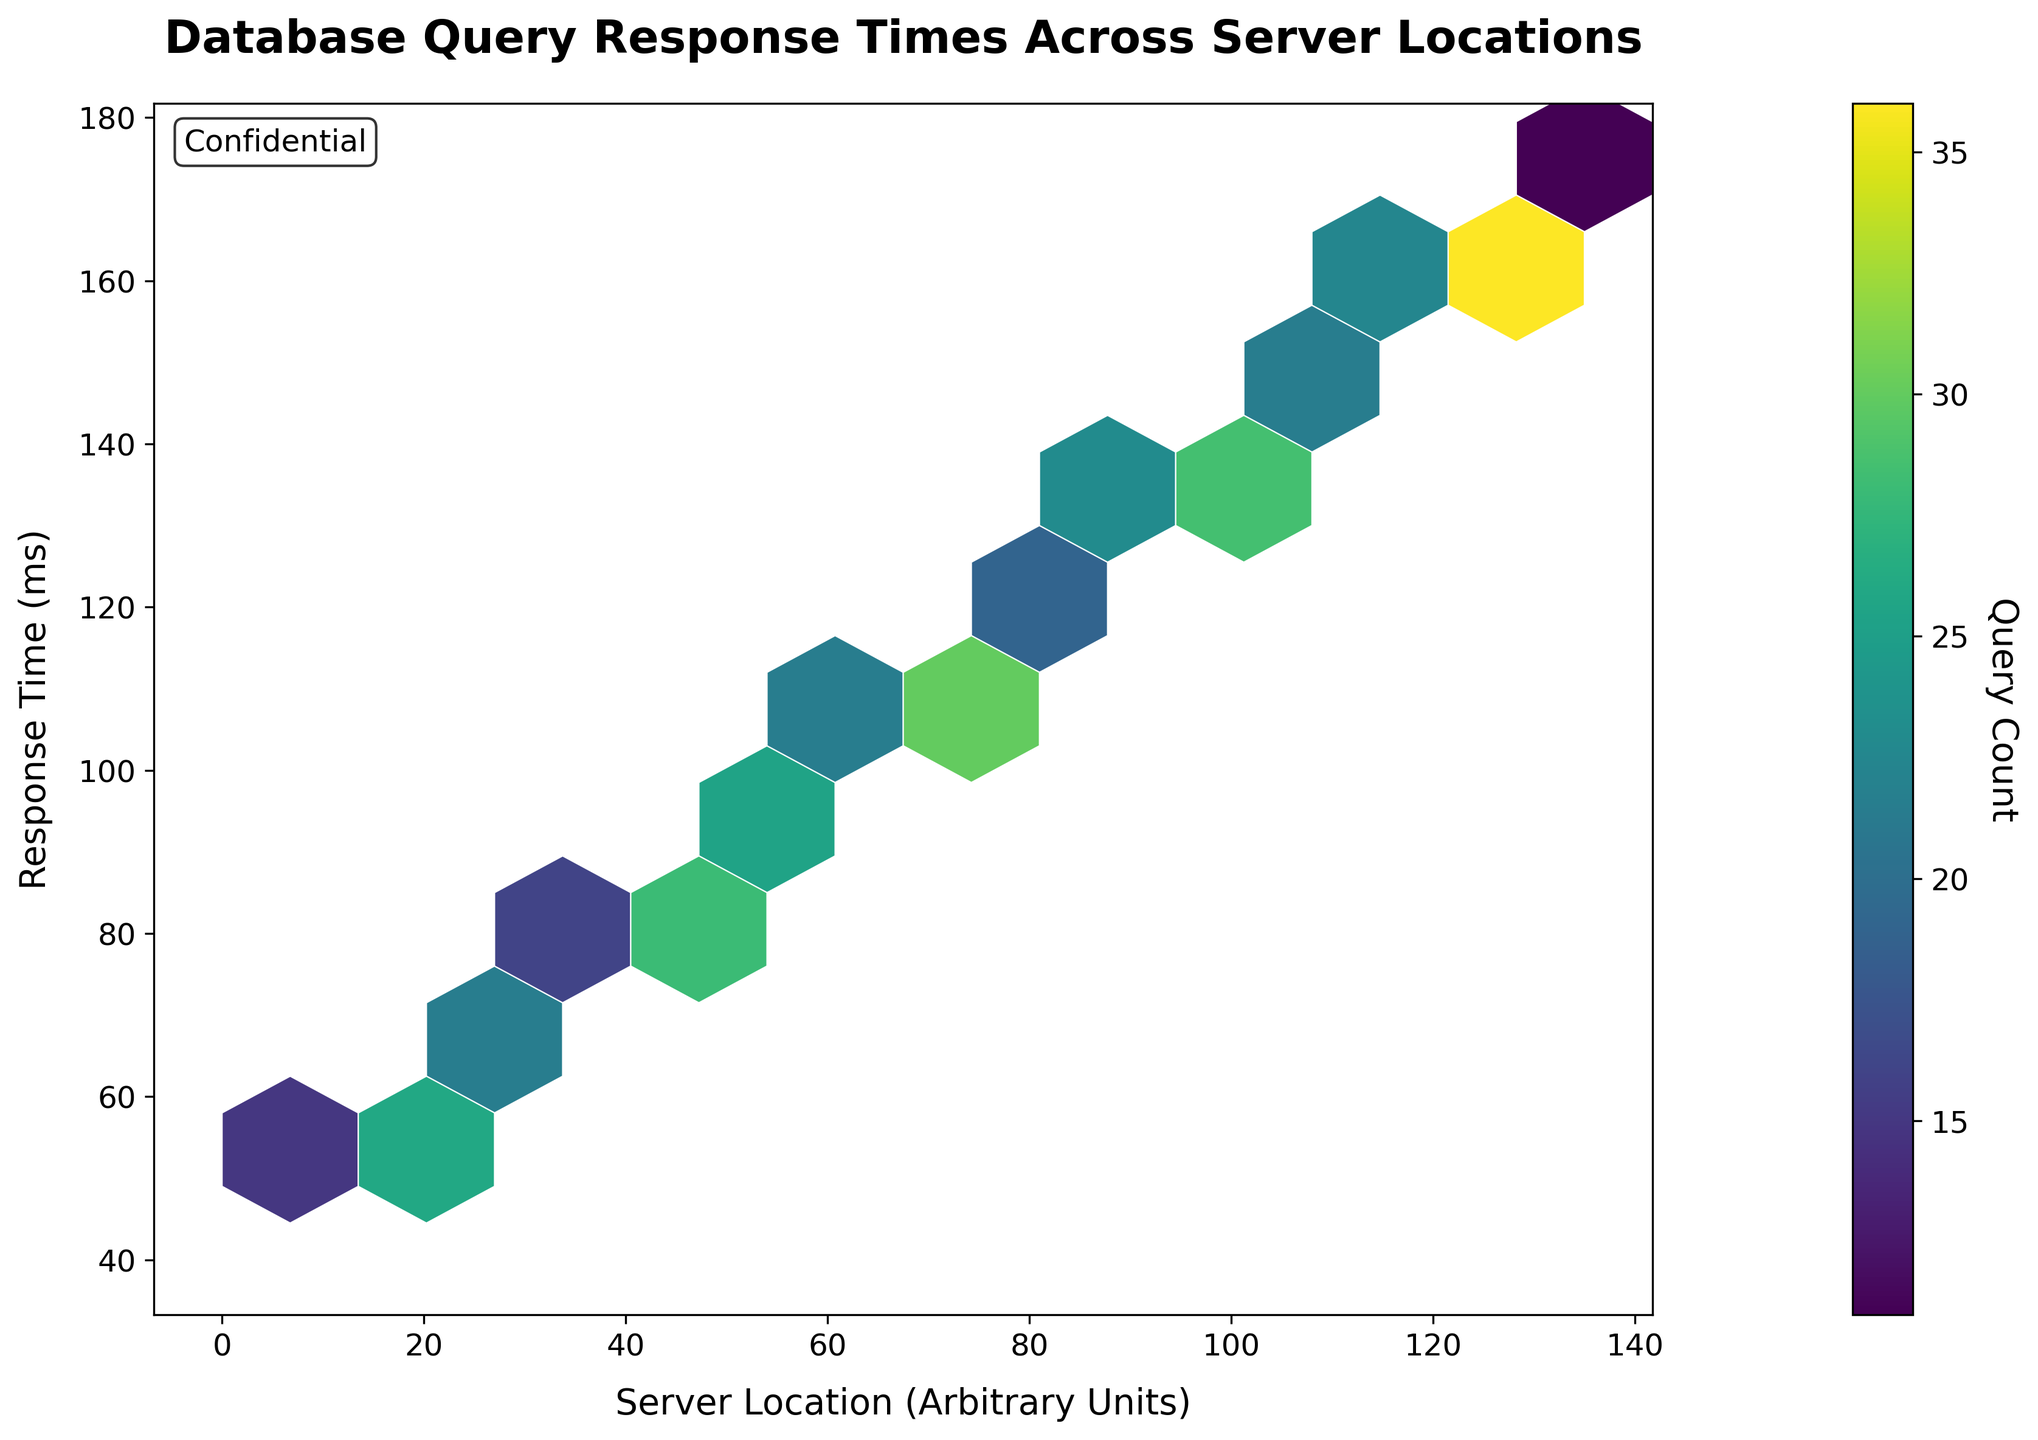What is the title of the figure? The title of the figure is displayed prominently at the top. It reads "Database Query Response Times Across Server Locations".
Answer: Database Query Response Times Across Server Locations What color scheme is used in the hexbin plot? The color scheme is described near the color bar legend; the plot uses the 'viridis' colormap, but the figure mostly shows different shades of green, yellow, blue, and purple.
Answer: viridis What are the units of the x-axis? The x-axis label provides information on the units, which are "Server Location (Arbitrary Units)".
Answer: Server Location (Arbitrary Units) What is the range of the y-axis? By looking at the y-axis, we see it ranges from 40 to 175.
Answer: 40 to 175 Which server location has the highest query count? The point with the highest query count can be identified by the darkest hexagons in the plot, corresponding to a location around 125 on the x-axis.
Answer: Around 125 What's the median server location for the queries plotted? Median server location can be found by ordering all x-values and identifying the middle one. With ordered values from 10 to 130, the median is halfway between locations 65 and 70.
Answer: 67.5 How many hexagons are displayed in the hexbin plot? Counting the visible hexagons in the plot involves considering the grid size of 10. The number of hexagons can be approximated by checking the horizontal and vertical extents shown in the figure.
Answer: Around 15-20 hexagons What is the approximate query count for the response time of 100ms? The color bar indicates the count, and hexagons shaded near y=100ms should be referenced to the color bar; hexagons at 100ms align with counts around 24.
Answer: About 24 For the server locations 105 and 115, which has a higher response time? Comparing hexagons at these locations, the hexagon at 115 is significantly darker and higher on the y-axis than at 105.
Answer: 115 Between server locations 90 and 70, which one has a lower query count and by what amount? Comparing the color intensity, server location 90 has a lighter shade compared to 70. The counts at 90 and 70 are 23 and 27 respectively, difference is 4.
Answer: 90 by 4 